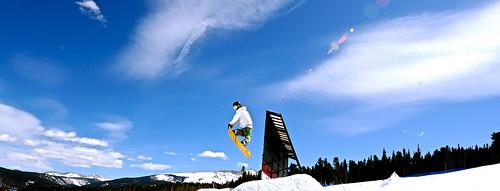What is the color of his shirt?
Keep it brief. White. Is he riding a bike?
Answer briefly. No. What is in the background?
Concise answer only. Sky. 